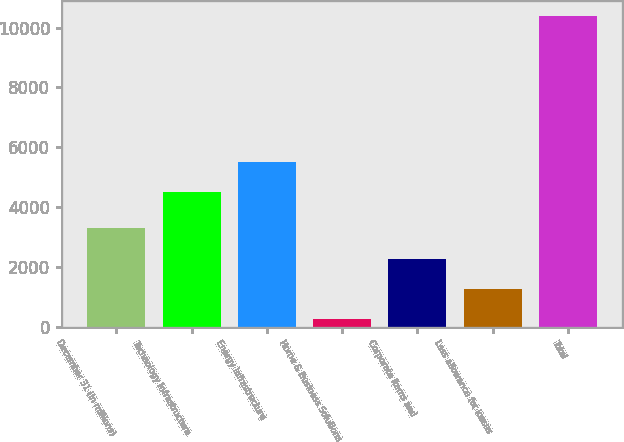Convert chart to OTSL. <chart><loc_0><loc_0><loc_500><loc_500><bar_chart><fcel>December 31 (In millions)<fcel>Technology Infrastructure<fcel>Energy Infrastructure<fcel>Home & Business Solutions<fcel>Corporate items and<fcel>Less allowance for losses<fcel>Total<nl><fcel>3282.9<fcel>4502<fcel>5516.3<fcel>240<fcel>2268.6<fcel>1254.3<fcel>10383<nl></chart> 